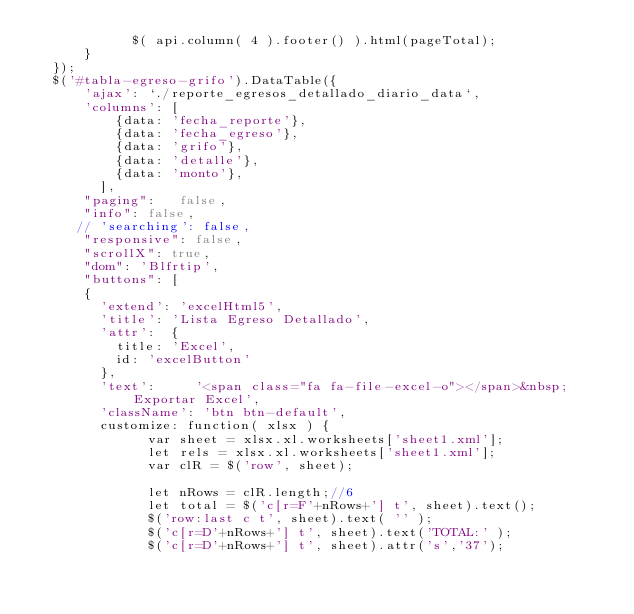<code> <loc_0><loc_0><loc_500><loc_500><_PHP_>            $( api.column( 4 ).footer() ).html(pageTotal);
      }
  });
  $('#tabla-egreso-grifo').DataTable({
      'ajax': `./reporte_egresos_detallado_diario_data`,
      'columns': [
          {data: 'fecha_reporte'},
          {data: 'fecha_egreso'},
          {data: 'grifo'},
          {data: 'detalle'},
          {data: 'monto'},
        ],
      "paging":   false,
      "info": false,
     // 'searching': false,    
      "responsive": false,
      "scrollX": true,
      "dom": 'Blfrtip',
      "buttons": [
      {
        'extend': 'excelHtml5',
        'title': 'Lista Egreso Detallado',
        'attr':  {
          title: 'Excel',
          id: 'excelButton'
        },
        'text':     '<span class="fa fa-file-excel-o"></span>&nbsp; Exportar Excel',
        'className': 'btn btn-default',
        customize: function( xlsx ) {
              var sheet = xlsx.xl.worksheets['sheet1.xml'];
              let rels = xlsx.xl.worksheets['sheet1.xml'];
              var clR = $('row', sheet); 
              
              let nRows = clR.length;//6
              let total = $('c[r=F'+nRows+'] t', sheet).text();                
              $('row:last c t', sheet).text( '' );
              $('c[r=D'+nRows+'] t', sheet).text('TOTAL:' );
              $('c[r=D'+nRows+'] t', sheet).attr('s','37');</code> 